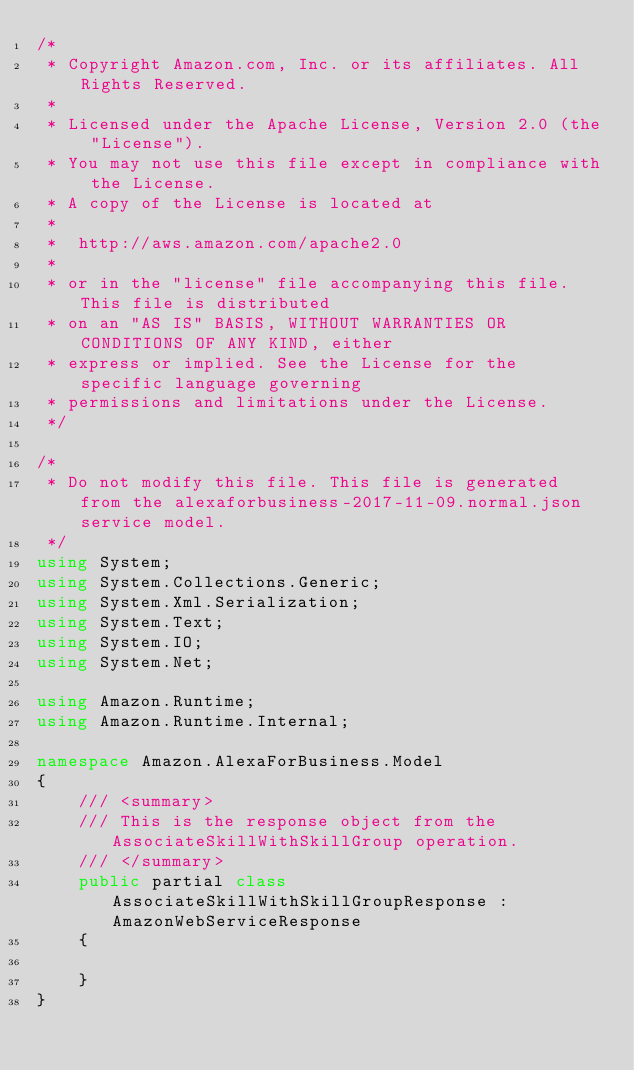Convert code to text. <code><loc_0><loc_0><loc_500><loc_500><_C#_>/*
 * Copyright Amazon.com, Inc. or its affiliates. All Rights Reserved.
 * 
 * Licensed under the Apache License, Version 2.0 (the "License").
 * You may not use this file except in compliance with the License.
 * A copy of the License is located at
 * 
 *  http://aws.amazon.com/apache2.0
 * 
 * or in the "license" file accompanying this file. This file is distributed
 * on an "AS IS" BASIS, WITHOUT WARRANTIES OR CONDITIONS OF ANY KIND, either
 * express or implied. See the License for the specific language governing
 * permissions and limitations under the License.
 */

/*
 * Do not modify this file. This file is generated from the alexaforbusiness-2017-11-09.normal.json service model.
 */
using System;
using System.Collections.Generic;
using System.Xml.Serialization;
using System.Text;
using System.IO;
using System.Net;

using Amazon.Runtime;
using Amazon.Runtime.Internal;

namespace Amazon.AlexaForBusiness.Model
{
    /// <summary>
    /// This is the response object from the AssociateSkillWithSkillGroup operation.
    /// </summary>
    public partial class AssociateSkillWithSkillGroupResponse : AmazonWebServiceResponse
    {

    }
}</code> 